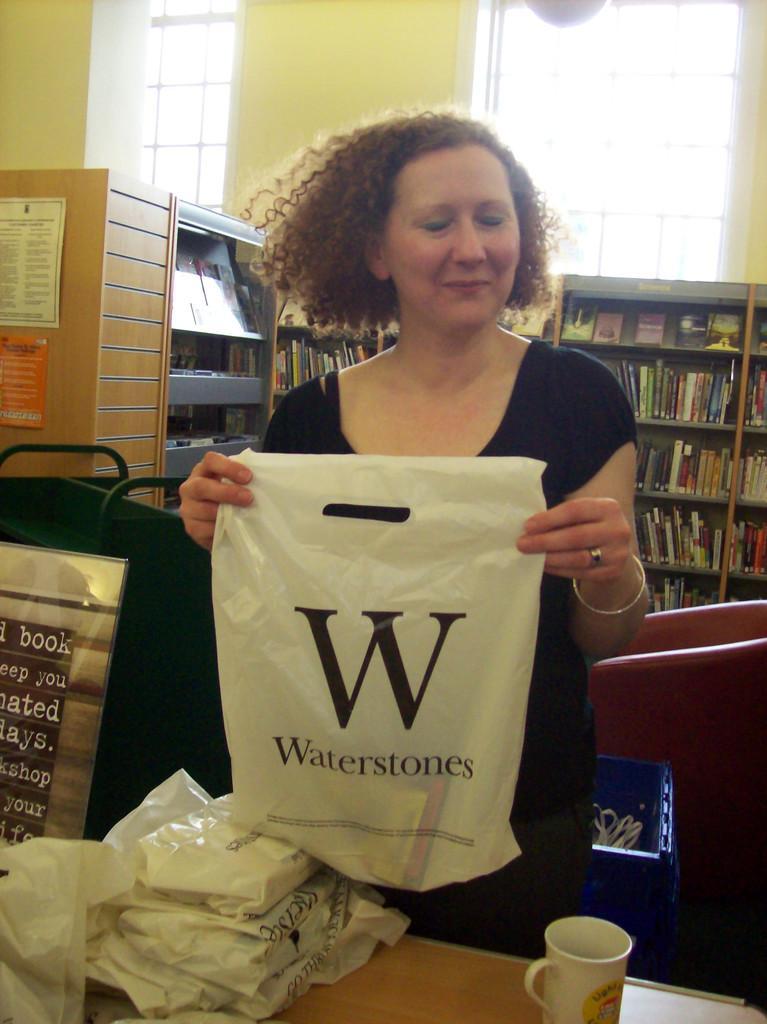In one or two sentences, can you explain what this image depicts? As we can see in the image, there is a woman holding a cover in her hand. In front of her there is a table. On table there are covers and a cup. Behind her there are shelves. In shelves there are lot of books. 